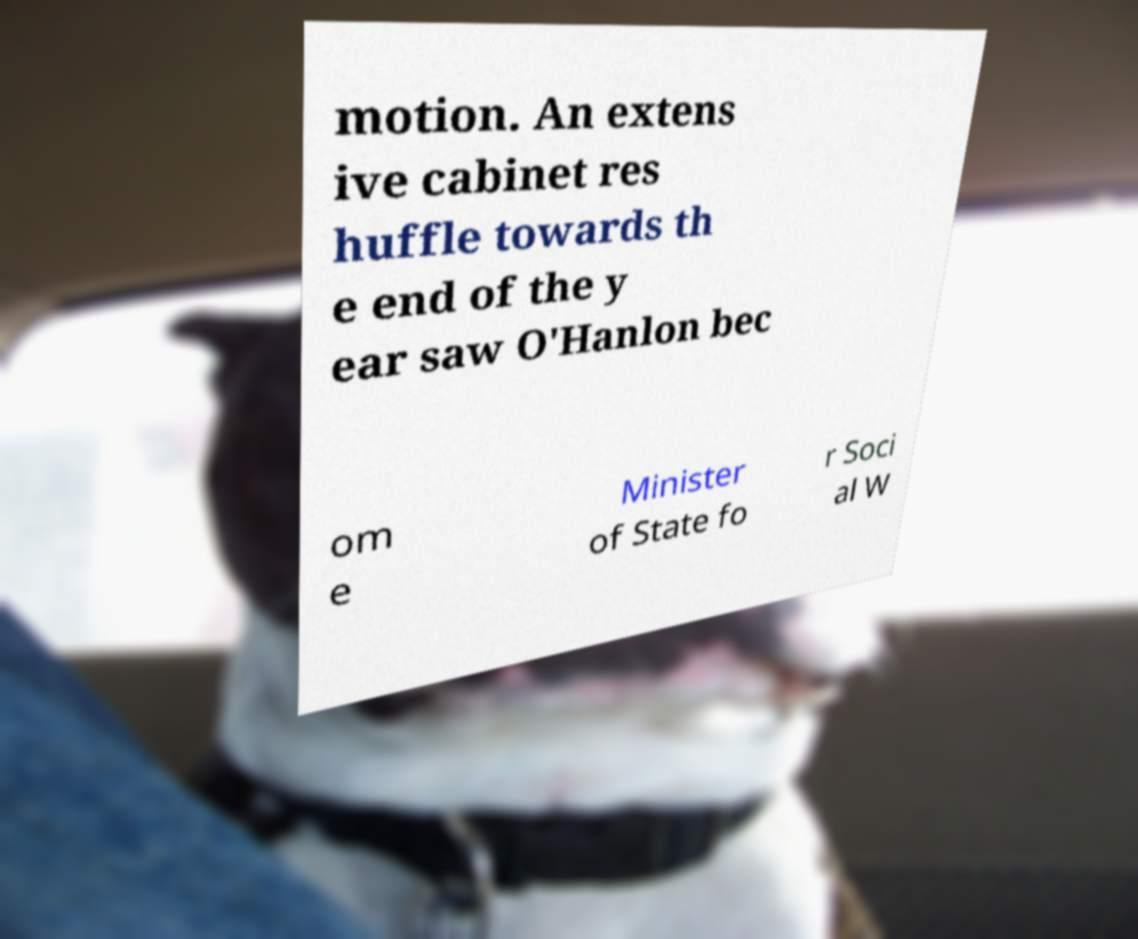Could you extract and type out the text from this image? motion. An extens ive cabinet res huffle towards th e end of the y ear saw O'Hanlon bec om e Minister of State fo r Soci al W 